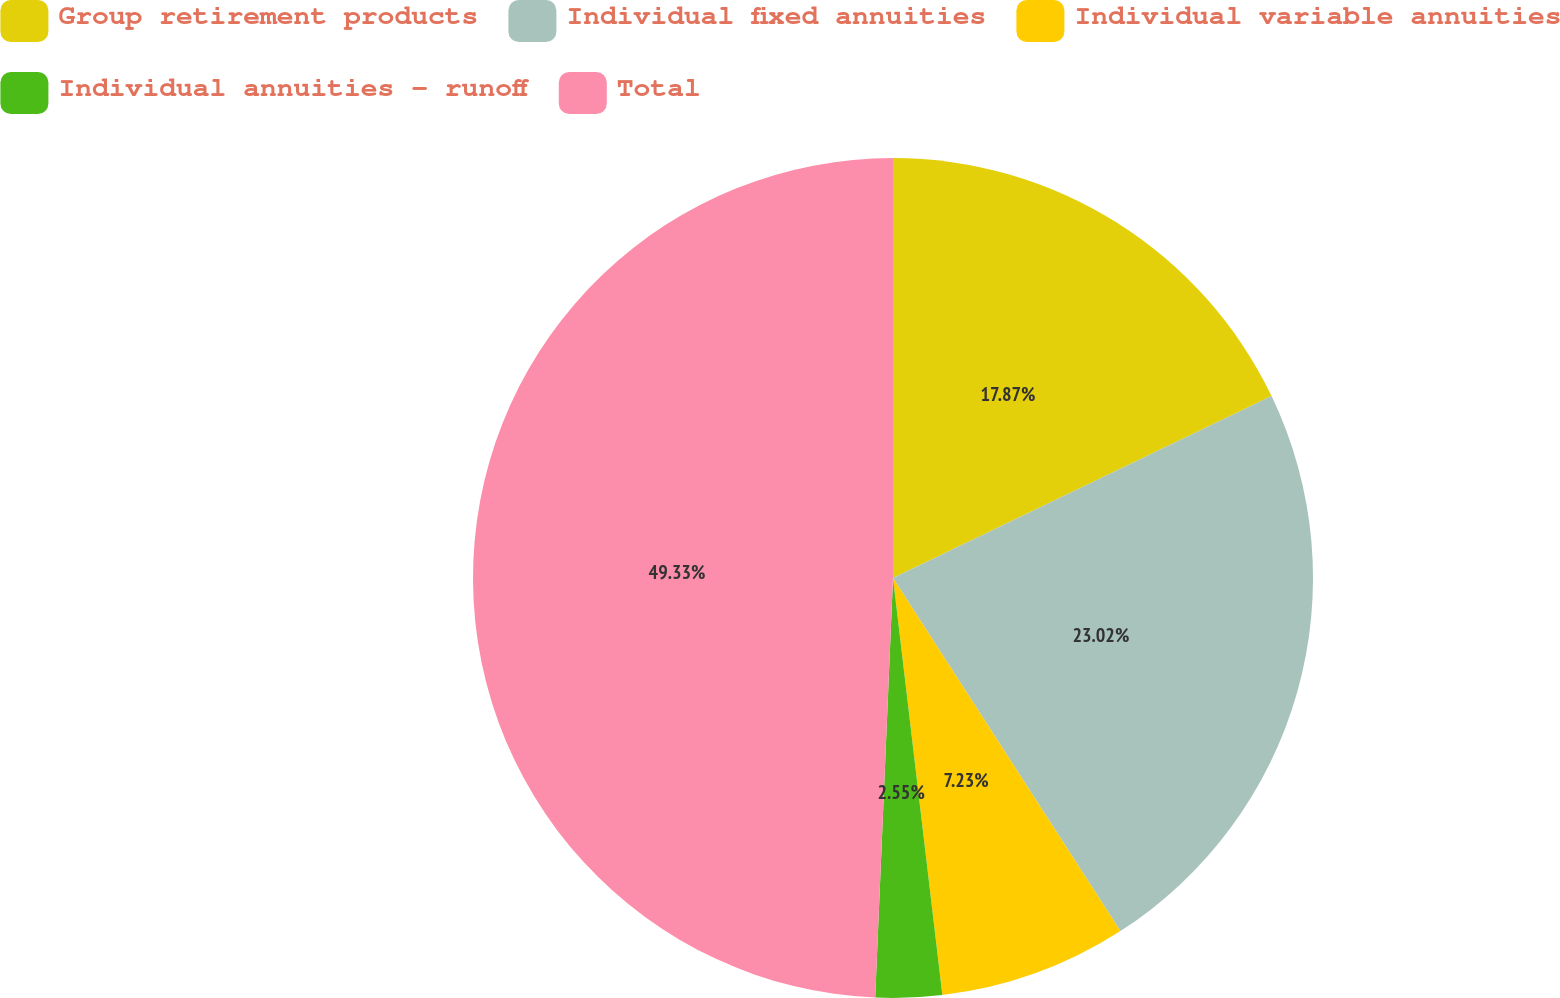Convert chart to OTSL. <chart><loc_0><loc_0><loc_500><loc_500><pie_chart><fcel>Group retirement products<fcel>Individual fixed annuities<fcel>Individual variable annuities<fcel>Individual annuities - runoff<fcel>Total<nl><fcel>17.87%<fcel>23.02%<fcel>7.23%<fcel>2.55%<fcel>49.32%<nl></chart> 